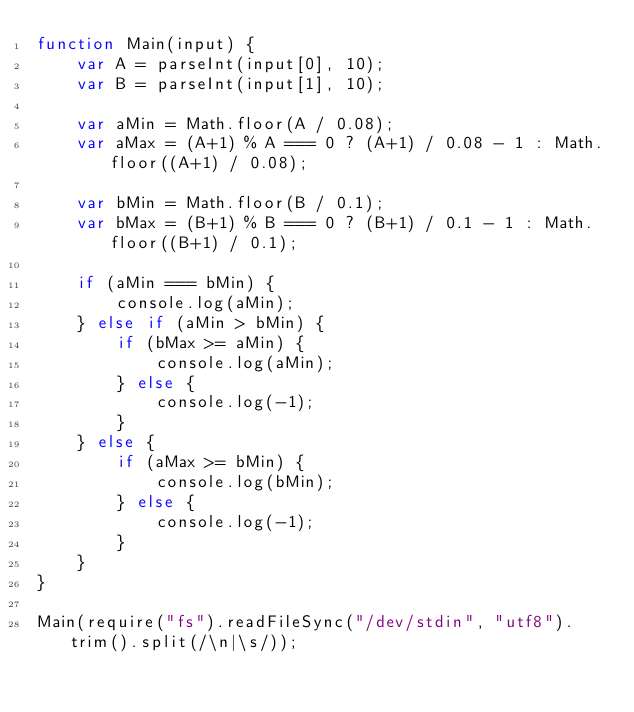<code> <loc_0><loc_0><loc_500><loc_500><_JavaScript_>function Main(input) {
    var A = parseInt(input[0], 10);
    var B = parseInt(input[1], 10);
    
    var aMin = Math.floor(A / 0.08);
    var aMax = (A+1) % A === 0 ? (A+1) / 0.08 - 1 : Math.floor((A+1) / 0.08);
    
    var bMin = Math.floor(B / 0.1);
    var bMax = (B+1) % B === 0 ? (B+1) / 0.1 - 1 : Math.floor((B+1) / 0.1);

    if (aMin === bMin) {
        console.log(aMin);
    } else if (aMin > bMin) {
        if (bMax >= aMin) {
            console.log(aMin);
        } else {
            console.log(-1);
        }
    } else {
        if (aMax >= bMin) {
            console.log(bMin);
        } else {
            console.log(-1);
        }
    }
}

Main(require("fs").readFileSync("/dev/stdin", "utf8").trim().split(/\n|\s/));</code> 